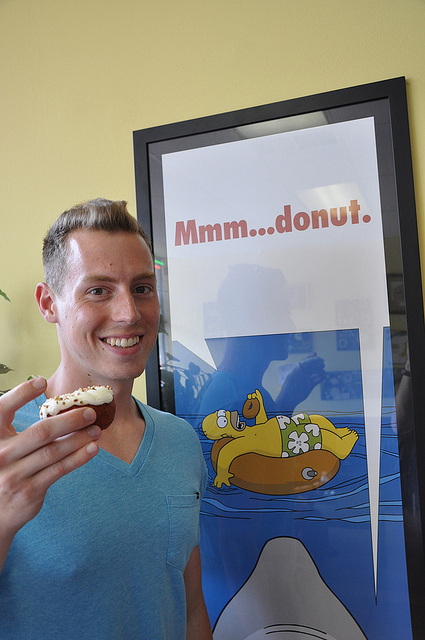Please extract the text content from this image. Mmm. donut 